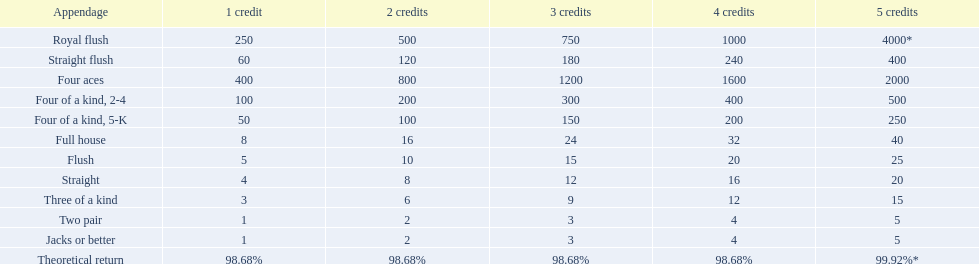What are each of the hands? Royal flush, Straight flush, Four aces, Four of a kind, 2-4, Four of a kind, 5-K, Full house, Flush, Straight, Three of a kind, Two pair, Jacks or better, Theoretical return. Which hand ranks higher between straights and flushes? Flush. 